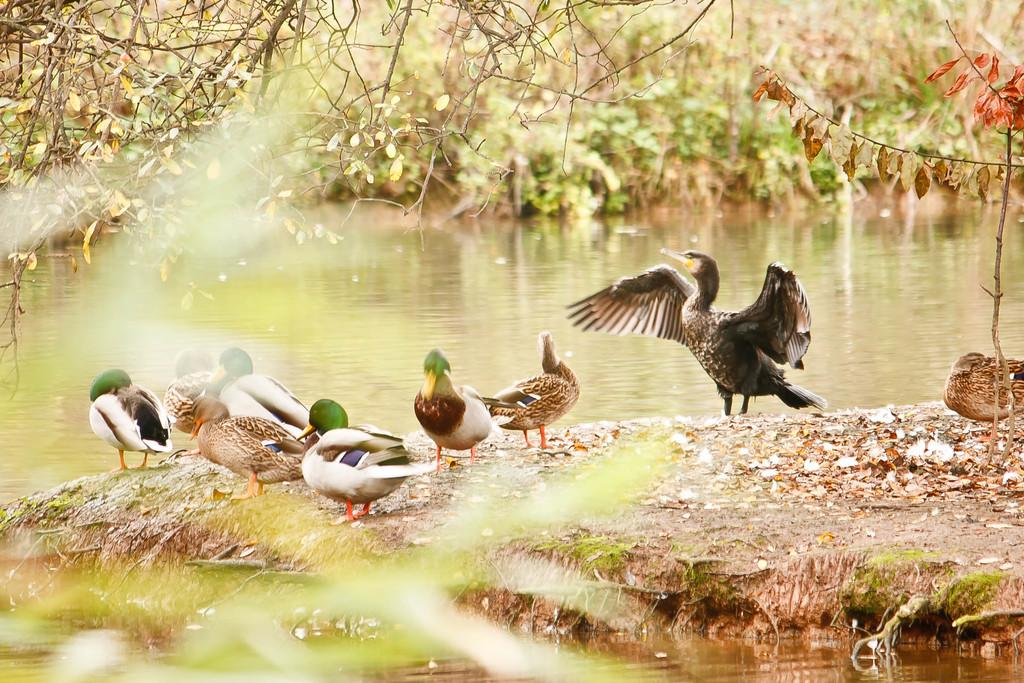What type of animals can be seen on the ground in the image? There are small ducks on the ground in the image. What is located near the ducks? There is a small pond with water in the image. What can be found around the pond? There are plants around the pond. What type of twig is being used as a musical instrument by the ducks in the image? There is no twig or musical instrument present in the image; it features small ducks near a pond with plants around it. 